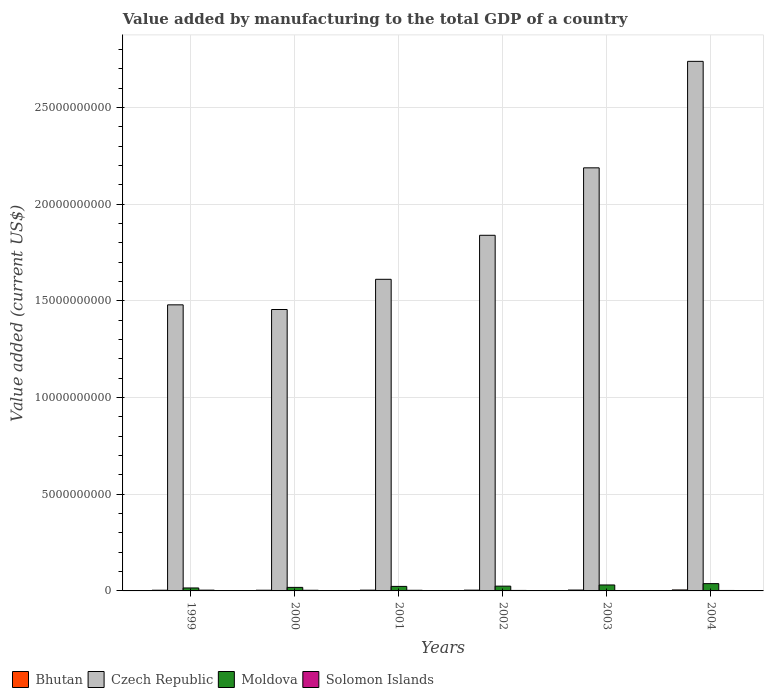Are the number of bars per tick equal to the number of legend labels?
Your answer should be very brief. Yes. In how many cases, is the number of bars for a given year not equal to the number of legend labels?
Your answer should be very brief. 0. What is the value added by manufacturing to the total GDP in Moldova in 2002?
Make the answer very short. 2.47e+08. Across all years, what is the maximum value added by manufacturing to the total GDP in Solomon Islands?
Your answer should be compact. 3.96e+07. Across all years, what is the minimum value added by manufacturing to the total GDP in Bhutan?
Make the answer very short. 3.60e+07. What is the total value added by manufacturing to the total GDP in Solomon Islands in the graph?
Your answer should be very brief. 1.75e+08. What is the difference between the value added by manufacturing to the total GDP in Moldova in 2002 and that in 2004?
Your answer should be very brief. -1.30e+08. What is the difference between the value added by manufacturing to the total GDP in Solomon Islands in 2000 and the value added by manufacturing to the total GDP in Czech Republic in 2003?
Provide a short and direct response. -2.19e+1. What is the average value added by manufacturing to the total GDP in Moldova per year?
Make the answer very short. 2.51e+08. In the year 2004, what is the difference between the value added by manufacturing to the total GDP in Czech Republic and value added by manufacturing to the total GDP in Solomon Islands?
Ensure brevity in your answer.  2.74e+1. In how many years, is the value added by manufacturing to the total GDP in Bhutan greater than 4000000000 US$?
Offer a terse response. 0. What is the ratio of the value added by manufacturing to the total GDP in Solomon Islands in 2003 to that in 2004?
Your answer should be very brief. 0.89. Is the value added by manufacturing to the total GDP in Bhutan in 1999 less than that in 2004?
Make the answer very short. Yes. What is the difference between the highest and the second highest value added by manufacturing to the total GDP in Solomon Islands?
Offer a terse response. 6.32e+06. What is the difference between the highest and the lowest value added by manufacturing to the total GDP in Solomon Islands?
Provide a succinct answer. 1.88e+07. What does the 2nd bar from the left in 2000 represents?
Offer a very short reply. Czech Republic. What does the 2nd bar from the right in 2000 represents?
Your answer should be compact. Moldova. Is it the case that in every year, the sum of the value added by manufacturing to the total GDP in Solomon Islands and value added by manufacturing to the total GDP in Czech Republic is greater than the value added by manufacturing to the total GDP in Bhutan?
Give a very brief answer. Yes. Are all the bars in the graph horizontal?
Offer a very short reply. No. What is the difference between two consecutive major ticks on the Y-axis?
Give a very brief answer. 5.00e+09. Does the graph contain any zero values?
Offer a very short reply. No. Where does the legend appear in the graph?
Offer a very short reply. Bottom left. How many legend labels are there?
Make the answer very short. 4. What is the title of the graph?
Ensure brevity in your answer.  Value added by manufacturing to the total GDP of a country. What is the label or title of the Y-axis?
Provide a short and direct response. Value added (current US$). What is the Value added (current US$) in Bhutan in 1999?
Offer a terse response. 3.62e+07. What is the Value added (current US$) in Czech Republic in 1999?
Your answer should be compact. 1.48e+1. What is the Value added (current US$) of Moldova in 1999?
Offer a very short reply. 1.53e+08. What is the Value added (current US$) of Solomon Islands in 1999?
Provide a short and direct response. 3.96e+07. What is the Value added (current US$) of Bhutan in 2000?
Offer a very short reply. 3.60e+07. What is the Value added (current US$) in Czech Republic in 2000?
Provide a succinct answer. 1.46e+1. What is the Value added (current US$) of Moldova in 2000?
Provide a short and direct response. 1.83e+08. What is the Value added (current US$) in Solomon Islands in 2000?
Keep it short and to the point. 3.33e+07. What is the Value added (current US$) of Bhutan in 2001?
Provide a succinct answer. 3.98e+07. What is the Value added (current US$) of Czech Republic in 2001?
Keep it short and to the point. 1.61e+1. What is the Value added (current US$) in Moldova in 2001?
Your response must be concise. 2.34e+08. What is the Value added (current US$) in Solomon Islands in 2001?
Your answer should be compact. 3.23e+07. What is the Value added (current US$) in Bhutan in 2002?
Your answer should be very brief. 3.98e+07. What is the Value added (current US$) of Czech Republic in 2002?
Your answer should be very brief. 1.84e+1. What is the Value added (current US$) in Moldova in 2002?
Give a very brief answer. 2.47e+08. What is the Value added (current US$) in Solomon Islands in 2002?
Your response must be concise. 2.56e+07. What is the Value added (current US$) in Bhutan in 2003?
Make the answer very short. 4.47e+07. What is the Value added (current US$) in Czech Republic in 2003?
Provide a short and direct response. 2.19e+1. What is the Value added (current US$) of Moldova in 2003?
Make the answer very short. 3.08e+08. What is the Value added (current US$) of Solomon Islands in 2003?
Offer a very short reply. 2.09e+07. What is the Value added (current US$) in Bhutan in 2004?
Your response must be concise. 5.07e+07. What is the Value added (current US$) of Czech Republic in 2004?
Keep it short and to the point. 2.74e+1. What is the Value added (current US$) in Moldova in 2004?
Offer a terse response. 3.77e+08. What is the Value added (current US$) of Solomon Islands in 2004?
Provide a short and direct response. 2.35e+07. Across all years, what is the maximum Value added (current US$) in Bhutan?
Keep it short and to the point. 5.07e+07. Across all years, what is the maximum Value added (current US$) in Czech Republic?
Your answer should be very brief. 2.74e+1. Across all years, what is the maximum Value added (current US$) in Moldova?
Ensure brevity in your answer.  3.77e+08. Across all years, what is the maximum Value added (current US$) of Solomon Islands?
Offer a very short reply. 3.96e+07. Across all years, what is the minimum Value added (current US$) of Bhutan?
Give a very brief answer. 3.60e+07. Across all years, what is the minimum Value added (current US$) of Czech Republic?
Your answer should be compact. 1.46e+1. Across all years, what is the minimum Value added (current US$) in Moldova?
Your response must be concise. 1.53e+08. Across all years, what is the minimum Value added (current US$) of Solomon Islands?
Your response must be concise. 2.09e+07. What is the total Value added (current US$) in Bhutan in the graph?
Keep it short and to the point. 2.47e+08. What is the total Value added (current US$) in Czech Republic in the graph?
Keep it short and to the point. 1.13e+11. What is the total Value added (current US$) of Moldova in the graph?
Give a very brief answer. 1.50e+09. What is the total Value added (current US$) of Solomon Islands in the graph?
Give a very brief answer. 1.75e+08. What is the difference between the Value added (current US$) in Bhutan in 1999 and that in 2000?
Make the answer very short. 1.33e+05. What is the difference between the Value added (current US$) of Czech Republic in 1999 and that in 2000?
Provide a succinct answer. 2.42e+08. What is the difference between the Value added (current US$) of Moldova in 1999 and that in 2000?
Your answer should be compact. -3.02e+07. What is the difference between the Value added (current US$) of Solomon Islands in 1999 and that in 2000?
Your answer should be compact. 6.32e+06. What is the difference between the Value added (current US$) in Bhutan in 1999 and that in 2001?
Your answer should be compact. -3.69e+06. What is the difference between the Value added (current US$) of Czech Republic in 1999 and that in 2001?
Your answer should be very brief. -1.32e+09. What is the difference between the Value added (current US$) of Moldova in 1999 and that in 2001?
Provide a succinct answer. -8.11e+07. What is the difference between the Value added (current US$) in Solomon Islands in 1999 and that in 2001?
Give a very brief answer. 7.33e+06. What is the difference between the Value added (current US$) in Bhutan in 1999 and that in 2002?
Ensure brevity in your answer.  -3.68e+06. What is the difference between the Value added (current US$) in Czech Republic in 1999 and that in 2002?
Make the answer very short. -3.60e+09. What is the difference between the Value added (current US$) of Moldova in 1999 and that in 2002?
Offer a very short reply. -9.37e+07. What is the difference between the Value added (current US$) in Solomon Islands in 1999 and that in 2002?
Provide a short and direct response. 1.40e+07. What is the difference between the Value added (current US$) of Bhutan in 1999 and that in 2003?
Your response must be concise. -8.59e+06. What is the difference between the Value added (current US$) of Czech Republic in 1999 and that in 2003?
Your response must be concise. -7.09e+09. What is the difference between the Value added (current US$) in Moldova in 1999 and that in 2003?
Provide a succinct answer. -1.55e+08. What is the difference between the Value added (current US$) of Solomon Islands in 1999 and that in 2003?
Provide a short and direct response. 1.88e+07. What is the difference between the Value added (current US$) of Bhutan in 1999 and that in 2004?
Your answer should be very brief. -1.45e+07. What is the difference between the Value added (current US$) in Czech Republic in 1999 and that in 2004?
Provide a short and direct response. -1.26e+1. What is the difference between the Value added (current US$) in Moldova in 1999 and that in 2004?
Ensure brevity in your answer.  -2.24e+08. What is the difference between the Value added (current US$) of Solomon Islands in 1999 and that in 2004?
Keep it short and to the point. 1.61e+07. What is the difference between the Value added (current US$) in Bhutan in 2000 and that in 2001?
Your response must be concise. -3.83e+06. What is the difference between the Value added (current US$) of Czech Republic in 2000 and that in 2001?
Keep it short and to the point. -1.56e+09. What is the difference between the Value added (current US$) of Moldova in 2000 and that in 2001?
Your response must be concise. -5.09e+07. What is the difference between the Value added (current US$) of Solomon Islands in 2000 and that in 2001?
Provide a succinct answer. 1.01e+06. What is the difference between the Value added (current US$) in Bhutan in 2000 and that in 2002?
Your response must be concise. -3.81e+06. What is the difference between the Value added (current US$) in Czech Republic in 2000 and that in 2002?
Make the answer very short. -3.84e+09. What is the difference between the Value added (current US$) in Moldova in 2000 and that in 2002?
Give a very brief answer. -6.36e+07. What is the difference between the Value added (current US$) of Solomon Islands in 2000 and that in 2002?
Make the answer very short. 7.71e+06. What is the difference between the Value added (current US$) of Bhutan in 2000 and that in 2003?
Provide a short and direct response. -8.72e+06. What is the difference between the Value added (current US$) of Czech Republic in 2000 and that in 2003?
Make the answer very short. -7.33e+09. What is the difference between the Value added (current US$) of Moldova in 2000 and that in 2003?
Offer a terse response. -1.25e+08. What is the difference between the Value added (current US$) of Solomon Islands in 2000 and that in 2003?
Give a very brief answer. 1.25e+07. What is the difference between the Value added (current US$) of Bhutan in 2000 and that in 2004?
Offer a terse response. -1.46e+07. What is the difference between the Value added (current US$) in Czech Republic in 2000 and that in 2004?
Provide a short and direct response. -1.28e+1. What is the difference between the Value added (current US$) of Moldova in 2000 and that in 2004?
Offer a terse response. -1.94e+08. What is the difference between the Value added (current US$) of Solomon Islands in 2000 and that in 2004?
Your answer should be very brief. 9.79e+06. What is the difference between the Value added (current US$) of Bhutan in 2001 and that in 2002?
Offer a terse response. 1.44e+04. What is the difference between the Value added (current US$) in Czech Republic in 2001 and that in 2002?
Make the answer very short. -2.28e+09. What is the difference between the Value added (current US$) of Moldova in 2001 and that in 2002?
Make the answer very short. -1.27e+07. What is the difference between the Value added (current US$) of Solomon Islands in 2001 and that in 2002?
Offer a terse response. 6.69e+06. What is the difference between the Value added (current US$) in Bhutan in 2001 and that in 2003?
Keep it short and to the point. -4.89e+06. What is the difference between the Value added (current US$) of Czech Republic in 2001 and that in 2003?
Give a very brief answer. -5.77e+09. What is the difference between the Value added (current US$) of Moldova in 2001 and that in 2003?
Your response must be concise. -7.37e+07. What is the difference between the Value added (current US$) in Solomon Islands in 2001 and that in 2003?
Provide a short and direct response. 1.15e+07. What is the difference between the Value added (current US$) of Bhutan in 2001 and that in 2004?
Ensure brevity in your answer.  -1.08e+07. What is the difference between the Value added (current US$) of Czech Republic in 2001 and that in 2004?
Provide a short and direct response. -1.13e+1. What is the difference between the Value added (current US$) of Moldova in 2001 and that in 2004?
Provide a succinct answer. -1.43e+08. What is the difference between the Value added (current US$) in Solomon Islands in 2001 and that in 2004?
Provide a short and direct response. 8.77e+06. What is the difference between the Value added (current US$) in Bhutan in 2002 and that in 2003?
Ensure brevity in your answer.  -4.91e+06. What is the difference between the Value added (current US$) in Czech Republic in 2002 and that in 2003?
Offer a very short reply. -3.49e+09. What is the difference between the Value added (current US$) in Moldova in 2002 and that in 2003?
Offer a terse response. -6.10e+07. What is the difference between the Value added (current US$) in Solomon Islands in 2002 and that in 2003?
Give a very brief answer. 4.76e+06. What is the difference between the Value added (current US$) in Bhutan in 2002 and that in 2004?
Your answer should be very brief. -1.08e+07. What is the difference between the Value added (current US$) in Czech Republic in 2002 and that in 2004?
Your answer should be very brief. -9.00e+09. What is the difference between the Value added (current US$) in Moldova in 2002 and that in 2004?
Give a very brief answer. -1.30e+08. What is the difference between the Value added (current US$) in Solomon Islands in 2002 and that in 2004?
Ensure brevity in your answer.  2.08e+06. What is the difference between the Value added (current US$) of Bhutan in 2003 and that in 2004?
Your answer should be very brief. -5.92e+06. What is the difference between the Value added (current US$) of Czech Republic in 2003 and that in 2004?
Ensure brevity in your answer.  -5.51e+09. What is the difference between the Value added (current US$) in Moldova in 2003 and that in 2004?
Keep it short and to the point. -6.92e+07. What is the difference between the Value added (current US$) in Solomon Islands in 2003 and that in 2004?
Offer a very short reply. -2.68e+06. What is the difference between the Value added (current US$) in Bhutan in 1999 and the Value added (current US$) in Czech Republic in 2000?
Provide a short and direct response. -1.45e+1. What is the difference between the Value added (current US$) in Bhutan in 1999 and the Value added (current US$) in Moldova in 2000?
Give a very brief answer. -1.47e+08. What is the difference between the Value added (current US$) of Bhutan in 1999 and the Value added (current US$) of Solomon Islands in 2000?
Give a very brief answer. 2.83e+06. What is the difference between the Value added (current US$) in Czech Republic in 1999 and the Value added (current US$) in Moldova in 2000?
Give a very brief answer. 1.46e+1. What is the difference between the Value added (current US$) of Czech Republic in 1999 and the Value added (current US$) of Solomon Islands in 2000?
Provide a short and direct response. 1.48e+1. What is the difference between the Value added (current US$) of Moldova in 1999 and the Value added (current US$) of Solomon Islands in 2000?
Your answer should be very brief. 1.20e+08. What is the difference between the Value added (current US$) of Bhutan in 1999 and the Value added (current US$) of Czech Republic in 2001?
Give a very brief answer. -1.61e+1. What is the difference between the Value added (current US$) in Bhutan in 1999 and the Value added (current US$) in Moldova in 2001?
Provide a short and direct response. -1.98e+08. What is the difference between the Value added (current US$) in Bhutan in 1999 and the Value added (current US$) in Solomon Islands in 2001?
Provide a succinct answer. 3.84e+06. What is the difference between the Value added (current US$) of Czech Republic in 1999 and the Value added (current US$) of Moldova in 2001?
Provide a short and direct response. 1.46e+1. What is the difference between the Value added (current US$) of Czech Republic in 1999 and the Value added (current US$) of Solomon Islands in 2001?
Offer a very short reply. 1.48e+1. What is the difference between the Value added (current US$) in Moldova in 1999 and the Value added (current US$) in Solomon Islands in 2001?
Make the answer very short. 1.21e+08. What is the difference between the Value added (current US$) of Bhutan in 1999 and the Value added (current US$) of Czech Republic in 2002?
Keep it short and to the point. -1.84e+1. What is the difference between the Value added (current US$) of Bhutan in 1999 and the Value added (current US$) of Moldova in 2002?
Your answer should be very brief. -2.11e+08. What is the difference between the Value added (current US$) of Bhutan in 1999 and the Value added (current US$) of Solomon Islands in 2002?
Offer a very short reply. 1.05e+07. What is the difference between the Value added (current US$) of Czech Republic in 1999 and the Value added (current US$) of Moldova in 2002?
Your answer should be very brief. 1.46e+1. What is the difference between the Value added (current US$) in Czech Republic in 1999 and the Value added (current US$) in Solomon Islands in 2002?
Keep it short and to the point. 1.48e+1. What is the difference between the Value added (current US$) in Moldova in 1999 and the Value added (current US$) in Solomon Islands in 2002?
Your answer should be very brief. 1.28e+08. What is the difference between the Value added (current US$) of Bhutan in 1999 and the Value added (current US$) of Czech Republic in 2003?
Make the answer very short. -2.18e+1. What is the difference between the Value added (current US$) in Bhutan in 1999 and the Value added (current US$) in Moldova in 2003?
Give a very brief answer. -2.72e+08. What is the difference between the Value added (current US$) of Bhutan in 1999 and the Value added (current US$) of Solomon Islands in 2003?
Provide a succinct answer. 1.53e+07. What is the difference between the Value added (current US$) of Czech Republic in 1999 and the Value added (current US$) of Moldova in 2003?
Offer a terse response. 1.45e+1. What is the difference between the Value added (current US$) of Czech Republic in 1999 and the Value added (current US$) of Solomon Islands in 2003?
Give a very brief answer. 1.48e+1. What is the difference between the Value added (current US$) in Moldova in 1999 and the Value added (current US$) in Solomon Islands in 2003?
Your answer should be compact. 1.32e+08. What is the difference between the Value added (current US$) of Bhutan in 1999 and the Value added (current US$) of Czech Republic in 2004?
Your answer should be very brief. -2.74e+1. What is the difference between the Value added (current US$) of Bhutan in 1999 and the Value added (current US$) of Moldova in 2004?
Your answer should be compact. -3.41e+08. What is the difference between the Value added (current US$) in Bhutan in 1999 and the Value added (current US$) in Solomon Islands in 2004?
Make the answer very short. 1.26e+07. What is the difference between the Value added (current US$) in Czech Republic in 1999 and the Value added (current US$) in Moldova in 2004?
Make the answer very short. 1.44e+1. What is the difference between the Value added (current US$) of Czech Republic in 1999 and the Value added (current US$) of Solomon Islands in 2004?
Provide a succinct answer. 1.48e+1. What is the difference between the Value added (current US$) of Moldova in 1999 and the Value added (current US$) of Solomon Islands in 2004?
Offer a terse response. 1.30e+08. What is the difference between the Value added (current US$) of Bhutan in 2000 and the Value added (current US$) of Czech Republic in 2001?
Provide a succinct answer. -1.61e+1. What is the difference between the Value added (current US$) of Bhutan in 2000 and the Value added (current US$) of Moldova in 2001?
Your response must be concise. -1.98e+08. What is the difference between the Value added (current US$) of Bhutan in 2000 and the Value added (current US$) of Solomon Islands in 2001?
Provide a succinct answer. 3.71e+06. What is the difference between the Value added (current US$) in Czech Republic in 2000 and the Value added (current US$) in Moldova in 2001?
Make the answer very short. 1.43e+1. What is the difference between the Value added (current US$) of Czech Republic in 2000 and the Value added (current US$) of Solomon Islands in 2001?
Your answer should be compact. 1.45e+1. What is the difference between the Value added (current US$) in Moldova in 2000 and the Value added (current US$) in Solomon Islands in 2001?
Your response must be concise. 1.51e+08. What is the difference between the Value added (current US$) of Bhutan in 2000 and the Value added (current US$) of Czech Republic in 2002?
Keep it short and to the point. -1.84e+1. What is the difference between the Value added (current US$) in Bhutan in 2000 and the Value added (current US$) in Moldova in 2002?
Your response must be concise. -2.11e+08. What is the difference between the Value added (current US$) in Bhutan in 2000 and the Value added (current US$) in Solomon Islands in 2002?
Ensure brevity in your answer.  1.04e+07. What is the difference between the Value added (current US$) of Czech Republic in 2000 and the Value added (current US$) of Moldova in 2002?
Your answer should be very brief. 1.43e+1. What is the difference between the Value added (current US$) of Czech Republic in 2000 and the Value added (current US$) of Solomon Islands in 2002?
Keep it short and to the point. 1.45e+1. What is the difference between the Value added (current US$) of Moldova in 2000 and the Value added (current US$) of Solomon Islands in 2002?
Offer a terse response. 1.58e+08. What is the difference between the Value added (current US$) of Bhutan in 2000 and the Value added (current US$) of Czech Republic in 2003?
Your answer should be very brief. -2.18e+1. What is the difference between the Value added (current US$) of Bhutan in 2000 and the Value added (current US$) of Moldova in 2003?
Give a very brief answer. -2.72e+08. What is the difference between the Value added (current US$) of Bhutan in 2000 and the Value added (current US$) of Solomon Islands in 2003?
Provide a short and direct response. 1.52e+07. What is the difference between the Value added (current US$) of Czech Republic in 2000 and the Value added (current US$) of Moldova in 2003?
Offer a very short reply. 1.42e+1. What is the difference between the Value added (current US$) in Czech Republic in 2000 and the Value added (current US$) in Solomon Islands in 2003?
Give a very brief answer. 1.45e+1. What is the difference between the Value added (current US$) of Moldova in 2000 and the Value added (current US$) of Solomon Islands in 2003?
Provide a succinct answer. 1.63e+08. What is the difference between the Value added (current US$) in Bhutan in 2000 and the Value added (current US$) in Czech Republic in 2004?
Keep it short and to the point. -2.74e+1. What is the difference between the Value added (current US$) in Bhutan in 2000 and the Value added (current US$) in Moldova in 2004?
Provide a short and direct response. -3.41e+08. What is the difference between the Value added (current US$) in Bhutan in 2000 and the Value added (current US$) in Solomon Islands in 2004?
Your response must be concise. 1.25e+07. What is the difference between the Value added (current US$) of Czech Republic in 2000 and the Value added (current US$) of Moldova in 2004?
Provide a short and direct response. 1.42e+1. What is the difference between the Value added (current US$) in Czech Republic in 2000 and the Value added (current US$) in Solomon Islands in 2004?
Give a very brief answer. 1.45e+1. What is the difference between the Value added (current US$) in Moldova in 2000 and the Value added (current US$) in Solomon Islands in 2004?
Provide a short and direct response. 1.60e+08. What is the difference between the Value added (current US$) in Bhutan in 2001 and the Value added (current US$) in Czech Republic in 2002?
Provide a succinct answer. -1.84e+1. What is the difference between the Value added (current US$) of Bhutan in 2001 and the Value added (current US$) of Moldova in 2002?
Offer a terse response. -2.07e+08. What is the difference between the Value added (current US$) of Bhutan in 2001 and the Value added (current US$) of Solomon Islands in 2002?
Ensure brevity in your answer.  1.42e+07. What is the difference between the Value added (current US$) of Czech Republic in 2001 and the Value added (current US$) of Moldova in 2002?
Offer a terse response. 1.59e+1. What is the difference between the Value added (current US$) of Czech Republic in 2001 and the Value added (current US$) of Solomon Islands in 2002?
Provide a short and direct response. 1.61e+1. What is the difference between the Value added (current US$) of Moldova in 2001 and the Value added (current US$) of Solomon Islands in 2002?
Keep it short and to the point. 2.09e+08. What is the difference between the Value added (current US$) in Bhutan in 2001 and the Value added (current US$) in Czech Republic in 2003?
Offer a very short reply. -2.18e+1. What is the difference between the Value added (current US$) in Bhutan in 2001 and the Value added (current US$) in Moldova in 2003?
Your response must be concise. -2.68e+08. What is the difference between the Value added (current US$) of Bhutan in 2001 and the Value added (current US$) of Solomon Islands in 2003?
Your response must be concise. 1.90e+07. What is the difference between the Value added (current US$) of Czech Republic in 2001 and the Value added (current US$) of Moldova in 2003?
Offer a very short reply. 1.58e+1. What is the difference between the Value added (current US$) in Czech Republic in 2001 and the Value added (current US$) in Solomon Islands in 2003?
Offer a very short reply. 1.61e+1. What is the difference between the Value added (current US$) of Moldova in 2001 and the Value added (current US$) of Solomon Islands in 2003?
Your answer should be compact. 2.13e+08. What is the difference between the Value added (current US$) of Bhutan in 2001 and the Value added (current US$) of Czech Republic in 2004?
Ensure brevity in your answer.  -2.74e+1. What is the difference between the Value added (current US$) of Bhutan in 2001 and the Value added (current US$) of Moldova in 2004?
Make the answer very short. -3.37e+08. What is the difference between the Value added (current US$) in Bhutan in 2001 and the Value added (current US$) in Solomon Islands in 2004?
Ensure brevity in your answer.  1.63e+07. What is the difference between the Value added (current US$) in Czech Republic in 2001 and the Value added (current US$) in Moldova in 2004?
Offer a terse response. 1.57e+1. What is the difference between the Value added (current US$) in Czech Republic in 2001 and the Value added (current US$) in Solomon Islands in 2004?
Provide a short and direct response. 1.61e+1. What is the difference between the Value added (current US$) in Moldova in 2001 and the Value added (current US$) in Solomon Islands in 2004?
Your response must be concise. 2.11e+08. What is the difference between the Value added (current US$) of Bhutan in 2002 and the Value added (current US$) of Czech Republic in 2003?
Your answer should be compact. -2.18e+1. What is the difference between the Value added (current US$) of Bhutan in 2002 and the Value added (current US$) of Moldova in 2003?
Provide a short and direct response. -2.68e+08. What is the difference between the Value added (current US$) of Bhutan in 2002 and the Value added (current US$) of Solomon Islands in 2003?
Your answer should be very brief. 1.90e+07. What is the difference between the Value added (current US$) of Czech Republic in 2002 and the Value added (current US$) of Moldova in 2003?
Make the answer very short. 1.81e+1. What is the difference between the Value added (current US$) of Czech Republic in 2002 and the Value added (current US$) of Solomon Islands in 2003?
Offer a terse response. 1.84e+1. What is the difference between the Value added (current US$) in Moldova in 2002 and the Value added (current US$) in Solomon Islands in 2003?
Your response must be concise. 2.26e+08. What is the difference between the Value added (current US$) of Bhutan in 2002 and the Value added (current US$) of Czech Republic in 2004?
Give a very brief answer. -2.74e+1. What is the difference between the Value added (current US$) of Bhutan in 2002 and the Value added (current US$) of Moldova in 2004?
Make the answer very short. -3.37e+08. What is the difference between the Value added (current US$) of Bhutan in 2002 and the Value added (current US$) of Solomon Islands in 2004?
Ensure brevity in your answer.  1.63e+07. What is the difference between the Value added (current US$) of Czech Republic in 2002 and the Value added (current US$) of Moldova in 2004?
Your answer should be very brief. 1.80e+1. What is the difference between the Value added (current US$) in Czech Republic in 2002 and the Value added (current US$) in Solomon Islands in 2004?
Offer a terse response. 1.84e+1. What is the difference between the Value added (current US$) of Moldova in 2002 and the Value added (current US$) of Solomon Islands in 2004?
Provide a short and direct response. 2.23e+08. What is the difference between the Value added (current US$) in Bhutan in 2003 and the Value added (current US$) in Czech Republic in 2004?
Your response must be concise. -2.73e+1. What is the difference between the Value added (current US$) in Bhutan in 2003 and the Value added (current US$) in Moldova in 2004?
Ensure brevity in your answer.  -3.33e+08. What is the difference between the Value added (current US$) of Bhutan in 2003 and the Value added (current US$) of Solomon Islands in 2004?
Provide a short and direct response. 2.12e+07. What is the difference between the Value added (current US$) in Czech Republic in 2003 and the Value added (current US$) in Moldova in 2004?
Provide a short and direct response. 2.15e+1. What is the difference between the Value added (current US$) of Czech Republic in 2003 and the Value added (current US$) of Solomon Islands in 2004?
Give a very brief answer. 2.19e+1. What is the difference between the Value added (current US$) in Moldova in 2003 and the Value added (current US$) in Solomon Islands in 2004?
Keep it short and to the point. 2.84e+08. What is the average Value added (current US$) of Bhutan per year?
Offer a terse response. 4.12e+07. What is the average Value added (current US$) in Czech Republic per year?
Offer a terse response. 1.89e+1. What is the average Value added (current US$) in Moldova per year?
Provide a succinct answer. 2.51e+08. What is the average Value added (current US$) of Solomon Islands per year?
Provide a short and direct response. 2.92e+07. In the year 1999, what is the difference between the Value added (current US$) of Bhutan and Value added (current US$) of Czech Republic?
Provide a succinct answer. -1.48e+1. In the year 1999, what is the difference between the Value added (current US$) of Bhutan and Value added (current US$) of Moldova?
Offer a very short reply. -1.17e+08. In the year 1999, what is the difference between the Value added (current US$) in Bhutan and Value added (current US$) in Solomon Islands?
Provide a succinct answer. -3.49e+06. In the year 1999, what is the difference between the Value added (current US$) of Czech Republic and Value added (current US$) of Moldova?
Keep it short and to the point. 1.46e+1. In the year 1999, what is the difference between the Value added (current US$) of Czech Republic and Value added (current US$) of Solomon Islands?
Make the answer very short. 1.48e+1. In the year 1999, what is the difference between the Value added (current US$) in Moldova and Value added (current US$) in Solomon Islands?
Offer a terse response. 1.14e+08. In the year 2000, what is the difference between the Value added (current US$) of Bhutan and Value added (current US$) of Czech Republic?
Provide a succinct answer. -1.45e+1. In the year 2000, what is the difference between the Value added (current US$) in Bhutan and Value added (current US$) in Moldova?
Give a very brief answer. -1.47e+08. In the year 2000, what is the difference between the Value added (current US$) in Bhutan and Value added (current US$) in Solomon Islands?
Keep it short and to the point. 2.70e+06. In the year 2000, what is the difference between the Value added (current US$) in Czech Republic and Value added (current US$) in Moldova?
Provide a short and direct response. 1.44e+1. In the year 2000, what is the difference between the Value added (current US$) of Czech Republic and Value added (current US$) of Solomon Islands?
Your response must be concise. 1.45e+1. In the year 2000, what is the difference between the Value added (current US$) in Moldova and Value added (current US$) in Solomon Islands?
Your answer should be compact. 1.50e+08. In the year 2001, what is the difference between the Value added (current US$) of Bhutan and Value added (current US$) of Czech Republic?
Offer a very short reply. -1.61e+1. In the year 2001, what is the difference between the Value added (current US$) of Bhutan and Value added (current US$) of Moldova?
Your response must be concise. -1.94e+08. In the year 2001, what is the difference between the Value added (current US$) in Bhutan and Value added (current US$) in Solomon Islands?
Offer a terse response. 7.54e+06. In the year 2001, what is the difference between the Value added (current US$) of Czech Republic and Value added (current US$) of Moldova?
Offer a very short reply. 1.59e+1. In the year 2001, what is the difference between the Value added (current US$) in Czech Republic and Value added (current US$) in Solomon Islands?
Offer a terse response. 1.61e+1. In the year 2001, what is the difference between the Value added (current US$) of Moldova and Value added (current US$) of Solomon Islands?
Your answer should be very brief. 2.02e+08. In the year 2002, what is the difference between the Value added (current US$) in Bhutan and Value added (current US$) in Czech Republic?
Make the answer very short. -1.84e+1. In the year 2002, what is the difference between the Value added (current US$) of Bhutan and Value added (current US$) of Moldova?
Offer a terse response. -2.07e+08. In the year 2002, what is the difference between the Value added (current US$) in Bhutan and Value added (current US$) in Solomon Islands?
Make the answer very short. 1.42e+07. In the year 2002, what is the difference between the Value added (current US$) of Czech Republic and Value added (current US$) of Moldova?
Provide a succinct answer. 1.81e+1. In the year 2002, what is the difference between the Value added (current US$) in Czech Republic and Value added (current US$) in Solomon Islands?
Your answer should be compact. 1.84e+1. In the year 2002, what is the difference between the Value added (current US$) of Moldova and Value added (current US$) of Solomon Islands?
Make the answer very short. 2.21e+08. In the year 2003, what is the difference between the Value added (current US$) of Bhutan and Value added (current US$) of Czech Republic?
Your answer should be compact. -2.18e+1. In the year 2003, what is the difference between the Value added (current US$) in Bhutan and Value added (current US$) in Moldova?
Provide a succinct answer. -2.63e+08. In the year 2003, what is the difference between the Value added (current US$) in Bhutan and Value added (current US$) in Solomon Islands?
Your answer should be compact. 2.39e+07. In the year 2003, what is the difference between the Value added (current US$) of Czech Republic and Value added (current US$) of Moldova?
Your response must be concise. 2.16e+1. In the year 2003, what is the difference between the Value added (current US$) of Czech Republic and Value added (current US$) of Solomon Islands?
Offer a very short reply. 2.19e+1. In the year 2003, what is the difference between the Value added (current US$) in Moldova and Value added (current US$) in Solomon Islands?
Provide a succinct answer. 2.87e+08. In the year 2004, what is the difference between the Value added (current US$) in Bhutan and Value added (current US$) in Czech Republic?
Make the answer very short. -2.73e+1. In the year 2004, what is the difference between the Value added (current US$) in Bhutan and Value added (current US$) in Moldova?
Give a very brief answer. -3.27e+08. In the year 2004, what is the difference between the Value added (current US$) in Bhutan and Value added (current US$) in Solomon Islands?
Give a very brief answer. 2.71e+07. In the year 2004, what is the difference between the Value added (current US$) of Czech Republic and Value added (current US$) of Moldova?
Your response must be concise. 2.70e+1. In the year 2004, what is the difference between the Value added (current US$) in Czech Republic and Value added (current US$) in Solomon Islands?
Make the answer very short. 2.74e+1. In the year 2004, what is the difference between the Value added (current US$) in Moldova and Value added (current US$) in Solomon Islands?
Provide a short and direct response. 3.54e+08. What is the ratio of the Value added (current US$) in Bhutan in 1999 to that in 2000?
Offer a very short reply. 1. What is the ratio of the Value added (current US$) of Czech Republic in 1999 to that in 2000?
Give a very brief answer. 1.02. What is the ratio of the Value added (current US$) of Moldova in 1999 to that in 2000?
Your answer should be very brief. 0.84. What is the ratio of the Value added (current US$) in Solomon Islands in 1999 to that in 2000?
Ensure brevity in your answer.  1.19. What is the ratio of the Value added (current US$) in Bhutan in 1999 to that in 2001?
Your answer should be very brief. 0.91. What is the ratio of the Value added (current US$) of Czech Republic in 1999 to that in 2001?
Make the answer very short. 0.92. What is the ratio of the Value added (current US$) in Moldova in 1999 to that in 2001?
Make the answer very short. 0.65. What is the ratio of the Value added (current US$) in Solomon Islands in 1999 to that in 2001?
Provide a short and direct response. 1.23. What is the ratio of the Value added (current US$) in Bhutan in 1999 to that in 2002?
Provide a short and direct response. 0.91. What is the ratio of the Value added (current US$) of Czech Republic in 1999 to that in 2002?
Your answer should be very brief. 0.8. What is the ratio of the Value added (current US$) in Moldova in 1999 to that in 2002?
Keep it short and to the point. 0.62. What is the ratio of the Value added (current US$) in Solomon Islands in 1999 to that in 2002?
Ensure brevity in your answer.  1.55. What is the ratio of the Value added (current US$) of Bhutan in 1999 to that in 2003?
Keep it short and to the point. 0.81. What is the ratio of the Value added (current US$) of Czech Republic in 1999 to that in 2003?
Make the answer very short. 0.68. What is the ratio of the Value added (current US$) in Moldova in 1999 to that in 2003?
Make the answer very short. 0.5. What is the ratio of the Value added (current US$) in Solomon Islands in 1999 to that in 2003?
Make the answer very short. 1.9. What is the ratio of the Value added (current US$) in Bhutan in 1999 to that in 2004?
Ensure brevity in your answer.  0.71. What is the ratio of the Value added (current US$) in Czech Republic in 1999 to that in 2004?
Offer a very short reply. 0.54. What is the ratio of the Value added (current US$) in Moldova in 1999 to that in 2004?
Keep it short and to the point. 0.41. What is the ratio of the Value added (current US$) in Solomon Islands in 1999 to that in 2004?
Your answer should be very brief. 1.68. What is the ratio of the Value added (current US$) in Bhutan in 2000 to that in 2001?
Your answer should be very brief. 0.9. What is the ratio of the Value added (current US$) in Czech Republic in 2000 to that in 2001?
Your response must be concise. 0.9. What is the ratio of the Value added (current US$) in Moldova in 2000 to that in 2001?
Your response must be concise. 0.78. What is the ratio of the Value added (current US$) of Solomon Islands in 2000 to that in 2001?
Ensure brevity in your answer.  1.03. What is the ratio of the Value added (current US$) of Bhutan in 2000 to that in 2002?
Your answer should be compact. 0.9. What is the ratio of the Value added (current US$) of Czech Republic in 2000 to that in 2002?
Give a very brief answer. 0.79. What is the ratio of the Value added (current US$) of Moldova in 2000 to that in 2002?
Your answer should be compact. 0.74. What is the ratio of the Value added (current US$) of Solomon Islands in 2000 to that in 2002?
Your answer should be very brief. 1.3. What is the ratio of the Value added (current US$) of Bhutan in 2000 to that in 2003?
Offer a very short reply. 0.81. What is the ratio of the Value added (current US$) in Czech Republic in 2000 to that in 2003?
Make the answer very short. 0.67. What is the ratio of the Value added (current US$) of Moldova in 2000 to that in 2003?
Provide a succinct answer. 0.6. What is the ratio of the Value added (current US$) in Solomon Islands in 2000 to that in 2003?
Provide a short and direct response. 1.6. What is the ratio of the Value added (current US$) in Bhutan in 2000 to that in 2004?
Ensure brevity in your answer.  0.71. What is the ratio of the Value added (current US$) in Czech Republic in 2000 to that in 2004?
Ensure brevity in your answer.  0.53. What is the ratio of the Value added (current US$) of Moldova in 2000 to that in 2004?
Ensure brevity in your answer.  0.49. What is the ratio of the Value added (current US$) in Solomon Islands in 2000 to that in 2004?
Keep it short and to the point. 1.42. What is the ratio of the Value added (current US$) of Bhutan in 2001 to that in 2002?
Provide a succinct answer. 1. What is the ratio of the Value added (current US$) in Czech Republic in 2001 to that in 2002?
Your answer should be very brief. 0.88. What is the ratio of the Value added (current US$) of Moldova in 2001 to that in 2002?
Your response must be concise. 0.95. What is the ratio of the Value added (current US$) in Solomon Islands in 2001 to that in 2002?
Offer a terse response. 1.26. What is the ratio of the Value added (current US$) of Bhutan in 2001 to that in 2003?
Offer a very short reply. 0.89. What is the ratio of the Value added (current US$) in Czech Republic in 2001 to that in 2003?
Your response must be concise. 0.74. What is the ratio of the Value added (current US$) in Moldova in 2001 to that in 2003?
Ensure brevity in your answer.  0.76. What is the ratio of the Value added (current US$) of Solomon Islands in 2001 to that in 2003?
Provide a short and direct response. 1.55. What is the ratio of the Value added (current US$) of Bhutan in 2001 to that in 2004?
Your response must be concise. 0.79. What is the ratio of the Value added (current US$) in Czech Republic in 2001 to that in 2004?
Offer a terse response. 0.59. What is the ratio of the Value added (current US$) in Moldova in 2001 to that in 2004?
Give a very brief answer. 0.62. What is the ratio of the Value added (current US$) in Solomon Islands in 2001 to that in 2004?
Give a very brief answer. 1.37. What is the ratio of the Value added (current US$) of Bhutan in 2002 to that in 2003?
Provide a short and direct response. 0.89. What is the ratio of the Value added (current US$) of Czech Republic in 2002 to that in 2003?
Your answer should be very brief. 0.84. What is the ratio of the Value added (current US$) of Moldova in 2002 to that in 2003?
Keep it short and to the point. 0.8. What is the ratio of the Value added (current US$) in Solomon Islands in 2002 to that in 2003?
Offer a very short reply. 1.23. What is the ratio of the Value added (current US$) in Bhutan in 2002 to that in 2004?
Your response must be concise. 0.79. What is the ratio of the Value added (current US$) in Czech Republic in 2002 to that in 2004?
Offer a terse response. 0.67. What is the ratio of the Value added (current US$) in Moldova in 2002 to that in 2004?
Offer a terse response. 0.65. What is the ratio of the Value added (current US$) of Solomon Islands in 2002 to that in 2004?
Ensure brevity in your answer.  1.09. What is the ratio of the Value added (current US$) of Bhutan in 2003 to that in 2004?
Your answer should be very brief. 0.88. What is the ratio of the Value added (current US$) of Czech Republic in 2003 to that in 2004?
Offer a very short reply. 0.8. What is the ratio of the Value added (current US$) of Moldova in 2003 to that in 2004?
Your answer should be compact. 0.82. What is the ratio of the Value added (current US$) of Solomon Islands in 2003 to that in 2004?
Keep it short and to the point. 0.89. What is the difference between the highest and the second highest Value added (current US$) of Bhutan?
Make the answer very short. 5.92e+06. What is the difference between the highest and the second highest Value added (current US$) of Czech Republic?
Your answer should be very brief. 5.51e+09. What is the difference between the highest and the second highest Value added (current US$) in Moldova?
Your answer should be very brief. 6.92e+07. What is the difference between the highest and the second highest Value added (current US$) in Solomon Islands?
Provide a succinct answer. 6.32e+06. What is the difference between the highest and the lowest Value added (current US$) in Bhutan?
Provide a succinct answer. 1.46e+07. What is the difference between the highest and the lowest Value added (current US$) in Czech Republic?
Your answer should be compact. 1.28e+1. What is the difference between the highest and the lowest Value added (current US$) in Moldova?
Your response must be concise. 2.24e+08. What is the difference between the highest and the lowest Value added (current US$) of Solomon Islands?
Make the answer very short. 1.88e+07. 